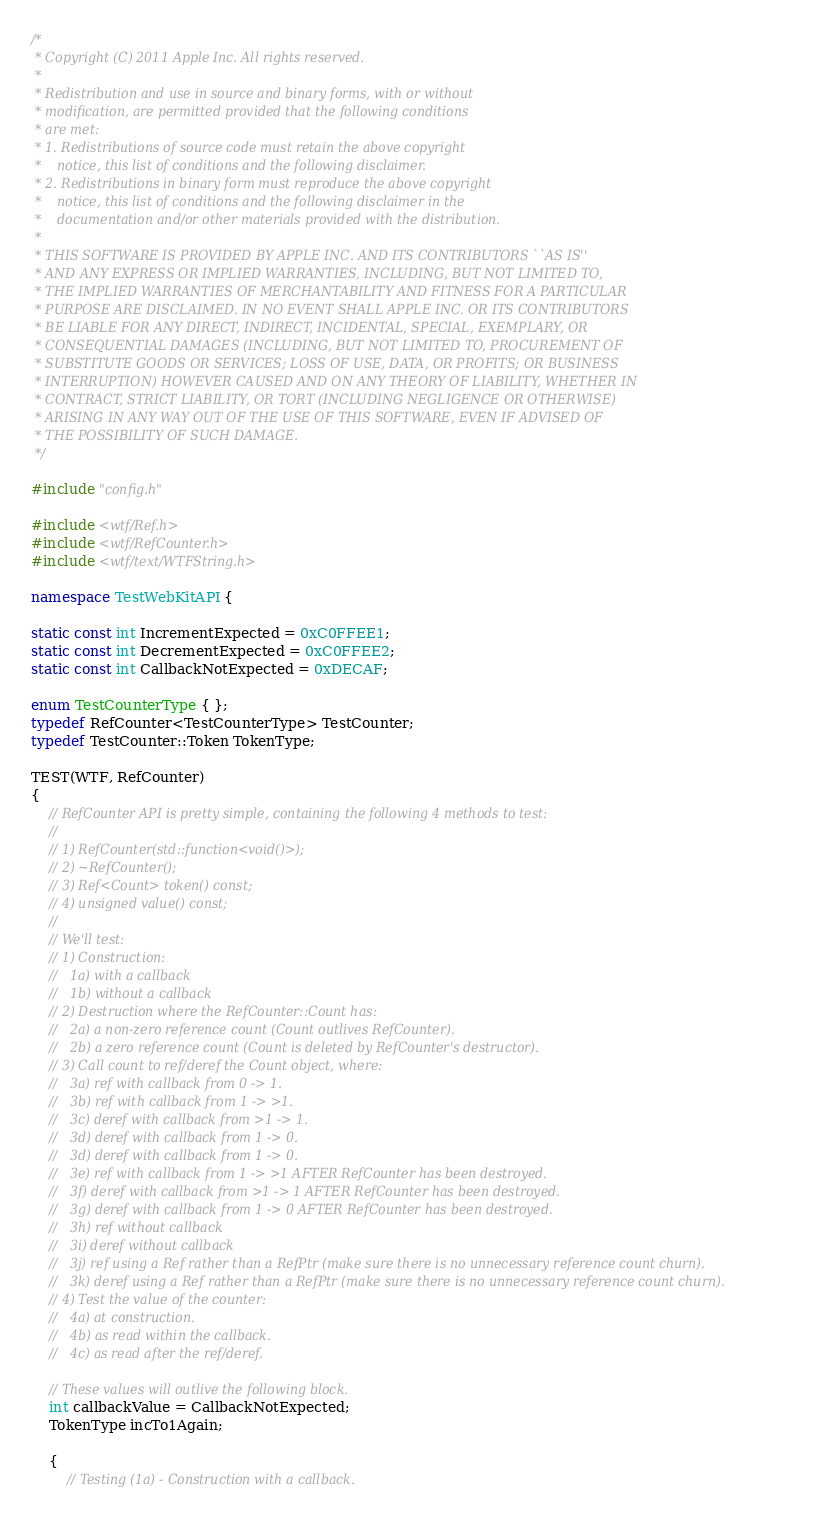Convert code to text. <code><loc_0><loc_0><loc_500><loc_500><_C++_>/*
 * Copyright (C) 2011 Apple Inc. All rights reserved.
 *
 * Redistribution and use in source and binary forms, with or without
 * modification, are permitted provided that the following conditions
 * are met:
 * 1. Redistributions of source code must retain the above copyright
 *    notice, this list of conditions and the following disclaimer.
 * 2. Redistributions in binary form must reproduce the above copyright
 *    notice, this list of conditions and the following disclaimer in the
 *    documentation and/or other materials provided with the distribution.
 *
 * THIS SOFTWARE IS PROVIDED BY APPLE INC. AND ITS CONTRIBUTORS ``AS IS''
 * AND ANY EXPRESS OR IMPLIED WARRANTIES, INCLUDING, BUT NOT LIMITED TO,
 * THE IMPLIED WARRANTIES OF MERCHANTABILITY AND FITNESS FOR A PARTICULAR
 * PURPOSE ARE DISCLAIMED. IN NO EVENT SHALL APPLE INC. OR ITS CONTRIBUTORS
 * BE LIABLE FOR ANY DIRECT, INDIRECT, INCIDENTAL, SPECIAL, EXEMPLARY, OR
 * CONSEQUENTIAL DAMAGES (INCLUDING, BUT NOT LIMITED TO, PROCUREMENT OF
 * SUBSTITUTE GOODS OR SERVICES; LOSS OF USE, DATA, OR PROFITS; OR BUSINESS
 * INTERRUPTION) HOWEVER CAUSED AND ON ANY THEORY OF LIABILITY, WHETHER IN
 * CONTRACT, STRICT LIABILITY, OR TORT (INCLUDING NEGLIGENCE OR OTHERWISE)
 * ARISING IN ANY WAY OUT OF THE USE OF THIS SOFTWARE, EVEN IF ADVISED OF
 * THE POSSIBILITY OF SUCH DAMAGE.
 */

#include "config.h"

#include <wtf/Ref.h>
#include <wtf/RefCounter.h>
#include <wtf/text/WTFString.h>

namespace TestWebKitAPI {

static const int IncrementExpected = 0xC0FFEE1;
static const int DecrementExpected = 0xC0FFEE2;
static const int CallbackNotExpected = 0xDECAF;

enum TestCounterType { };
typedef RefCounter<TestCounterType> TestCounter;
typedef TestCounter::Token TokenType;

TEST(WTF, RefCounter)
{
    // RefCounter API is pretty simple, containing the following 4 methods to test:
    //
    // 1) RefCounter(std::function<void()>);
    // 2) ~RefCounter();
    // 3) Ref<Count> token() const;
    // 4) unsigned value() const;
    //
    // We'll test:
    // 1) Construction:
    //   1a) with a callback
    //   1b) without a callback
    // 2) Destruction where the RefCounter::Count has:
    //   2a) a non-zero reference count (Count outlives RefCounter).
    //   2b) a zero reference count (Count is deleted by RefCounter's destructor).
    // 3) Call count to ref/deref the Count object, where:
    //   3a) ref with callback from 0 -> 1.
    //   3b) ref with callback from 1 -> >1.
    //   3c) deref with callback from >1 -> 1.
    //   3d) deref with callback from 1 -> 0.
    //   3d) deref with callback from 1 -> 0.
    //   3e) ref with callback from 1 -> >1 AFTER RefCounter has been destroyed.
    //   3f) deref with callback from >1 -> 1 AFTER RefCounter has been destroyed.
    //   3g) deref with callback from 1 -> 0 AFTER RefCounter has been destroyed.
    //   3h) ref without callback
    //   3i) deref without callback
    //   3j) ref using a Ref rather than a RefPtr (make sure there is no unnecessary reference count churn).
    //   3k) deref using a Ref rather than a RefPtr (make sure there is no unnecessary reference count churn).
    // 4) Test the value of the counter:
    //   4a) at construction.
    //   4b) as read within the callback.
    //   4c) as read after the ref/deref.

    // These values will outlive the following block.
    int callbackValue = CallbackNotExpected;
    TokenType incTo1Again;

    {
        // Testing (1a) - Construction with a callback.</code> 